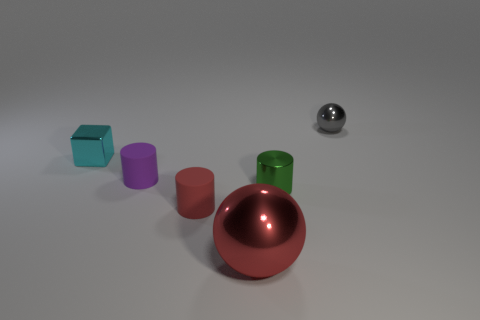Can you describe the lighting conditions in the scene? The lighting in the scene is soft and diffused, likely from an overhead source. There are subtle shadows under each object, suggesting the light is not directly overhead but placed at a slight angle. 